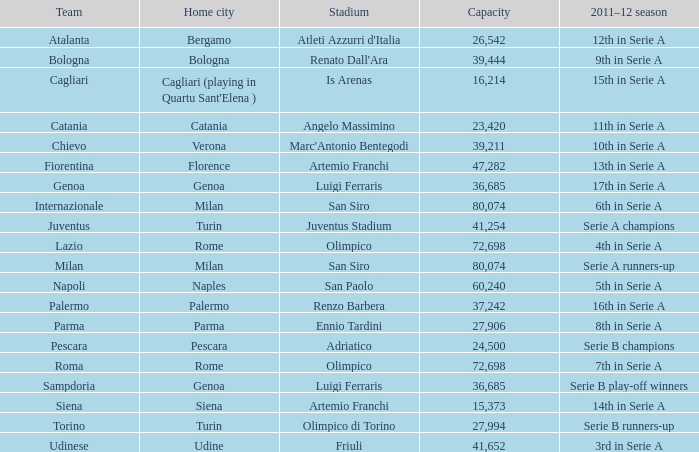What is the home city for angelo massimino stadium? Catania. 